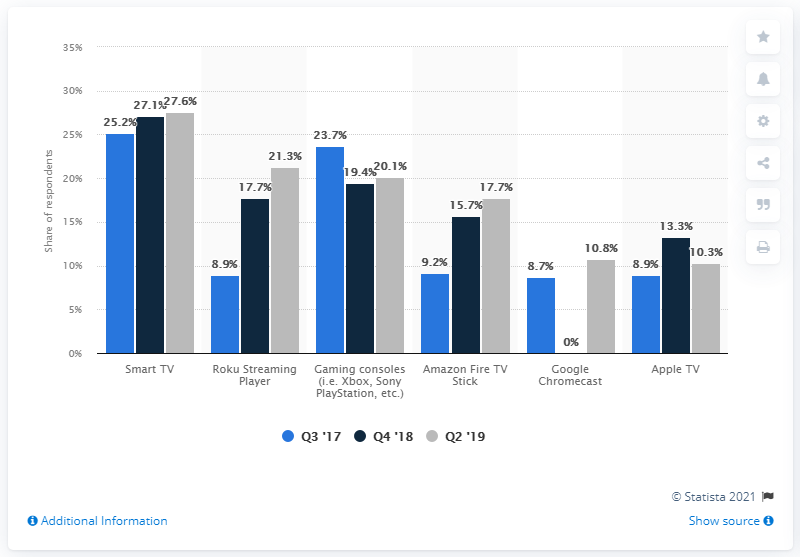Highlight a few significant elements in this photo. In Q3 2017, 25.2% of Americans and Canadians reported owning a smart TV. In the second quarter of 2019, 27.6% of Americans and Canadians reported owning a smart TV. 